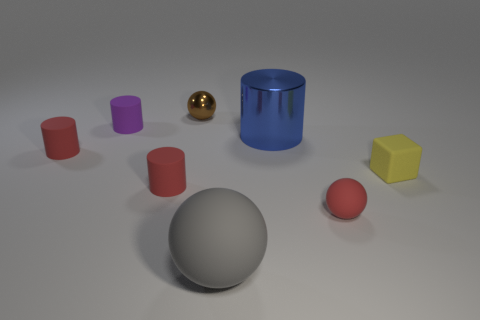What materials do these objects appear to be made of? The objects in the image have a variety of textures suggesting different materials. The spheres and cylinders look to have a smooth, possibly plastic finish, with the exception of the golden sphere which has a metallic sheen indicative of metal. The cube also appears to have a smooth plastic-like material. 